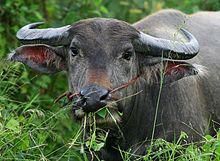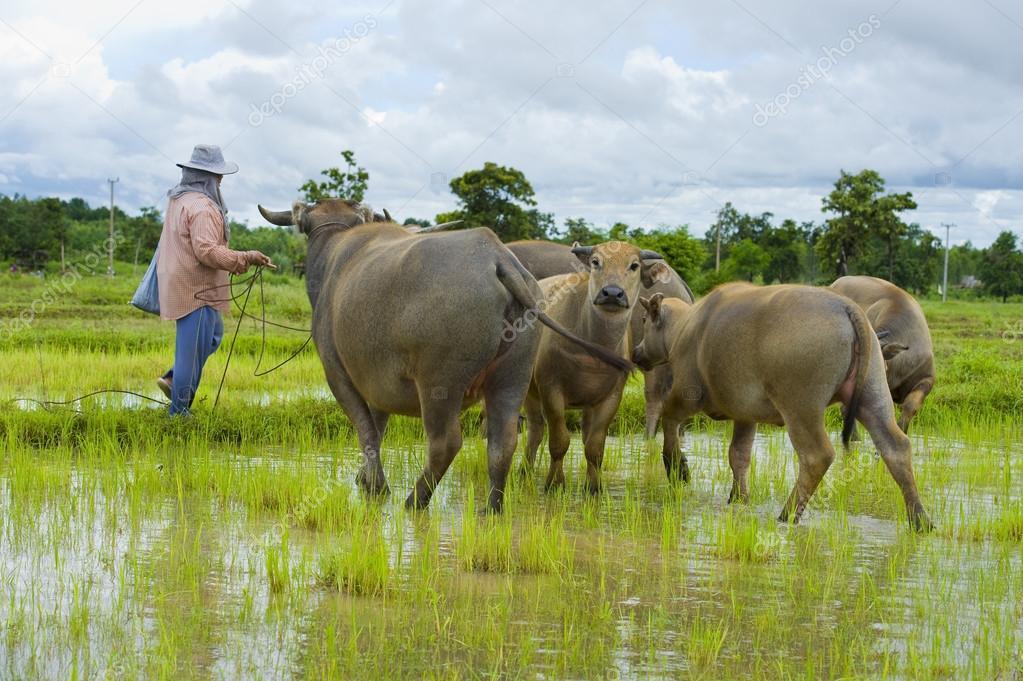The first image is the image on the left, the second image is the image on the right. Given the left and right images, does the statement "At least one image has more than one animal." hold true? Answer yes or no. Yes. 